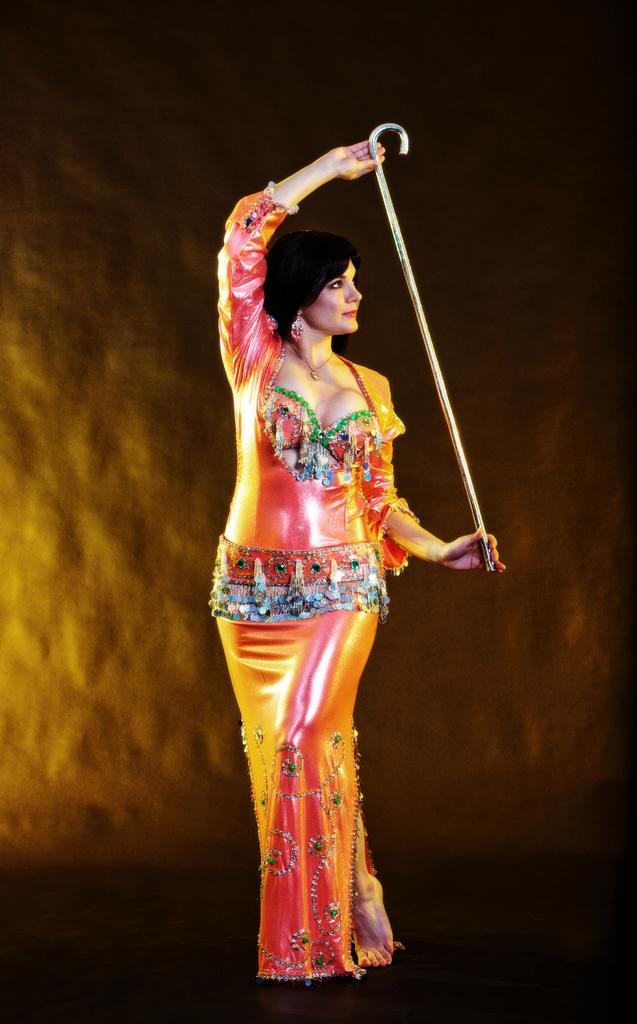What is the main subject of the image? There is a woman in the image. What is the woman holding in her hand? The woman is holding a stick in her hand. Where is the woman standing? The woman is standing on the ground. What can be seen in the background of the image? There is a stone wall in the background of the image. Can you tell if the image was taken during the day or night? The image may have been taken during the night. How many fingers can be seen on the woman's hand in the image? The image does not show the woman's fingers, only the stick she is holding. Is there a volcano visible in the image? No, there is no volcano present in the image. 